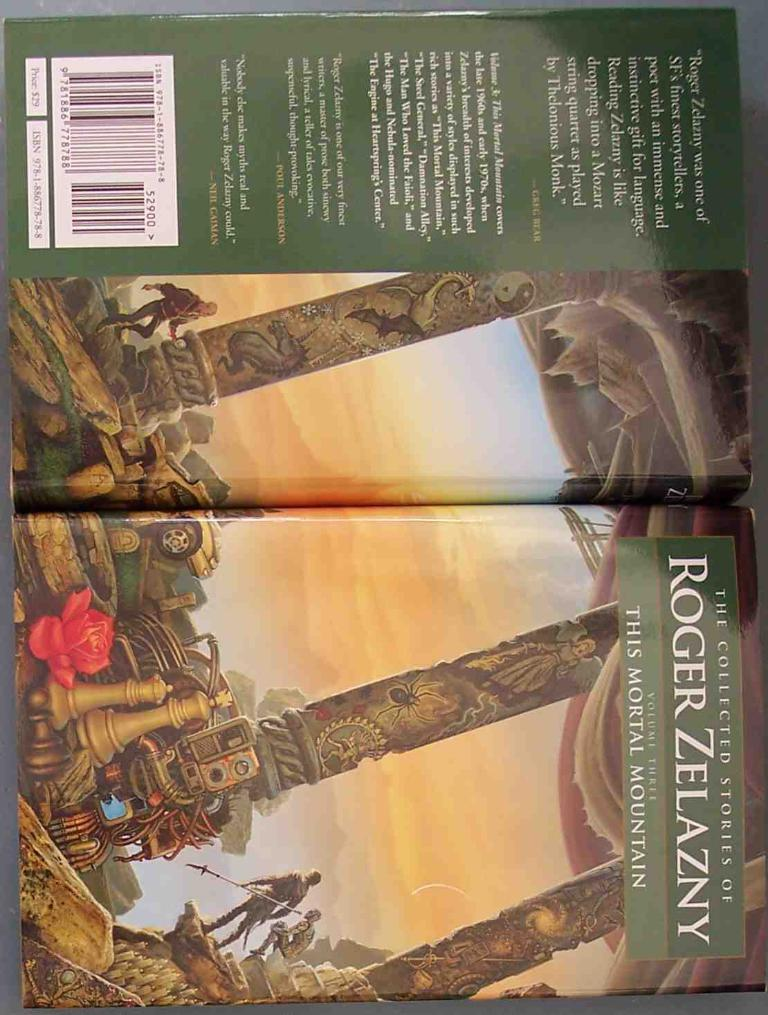<image>
Create a compact narrative representing the image presented. A display showing the back and front of the collected stories of Roger Zelazny. 